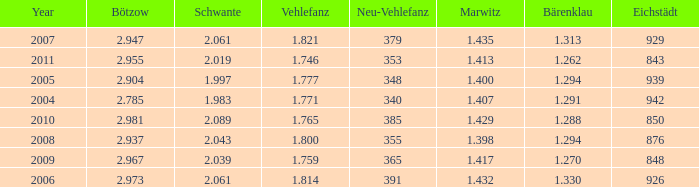Could you parse the entire table? {'header': ['Year', 'Bötzow', 'Schwante', 'Vehlefanz', 'Neu-Vehlefanz', 'Marwitz', 'Bärenklau', 'Eichstädt'], 'rows': [['2007', '2.947', '2.061', '1.821', '379', '1.435', '1.313', '929'], ['2011', '2.955', '2.019', '1.746', '353', '1.413', '1.262', '843'], ['2005', '2.904', '1.997', '1.777', '348', '1.400', '1.294', '939'], ['2004', '2.785', '1.983', '1.771', '340', '1.407', '1.291', '942'], ['2010', '2.981', '2.089', '1.765', '385', '1.429', '1.288', '850'], ['2008', '2.937', '2.043', '1.800', '355', '1.398', '1.294', '876'], ['2009', '2.967', '2.039', '1.759', '365', '1.417', '1.270', '848'], ['2006', '2.973', '2.061', '1.814', '391', '1.432', '1.330', '926']]} What year has a Schwante smaller than 2.043, an Eichstädt smaller than 848, and a Bärenklau smaller than 1.262? 0.0. 